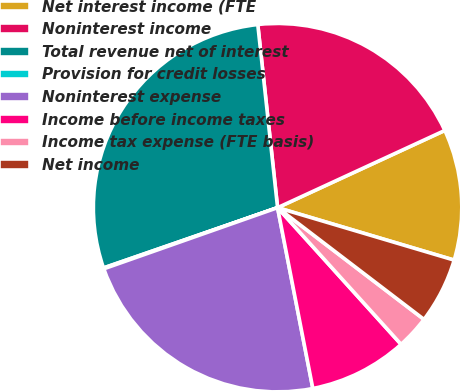<chart> <loc_0><loc_0><loc_500><loc_500><pie_chart><fcel>Net interest income (FTE<fcel>Noninterest income<fcel>Total revenue net of interest<fcel>Provision for credit losses<fcel>Noninterest expense<fcel>Income before income taxes<fcel>Income tax expense (FTE basis)<fcel>Net income<nl><fcel>11.48%<fcel>19.83%<fcel>28.59%<fcel>0.08%<fcel>22.68%<fcel>8.63%<fcel>2.93%<fcel>5.78%<nl></chart> 